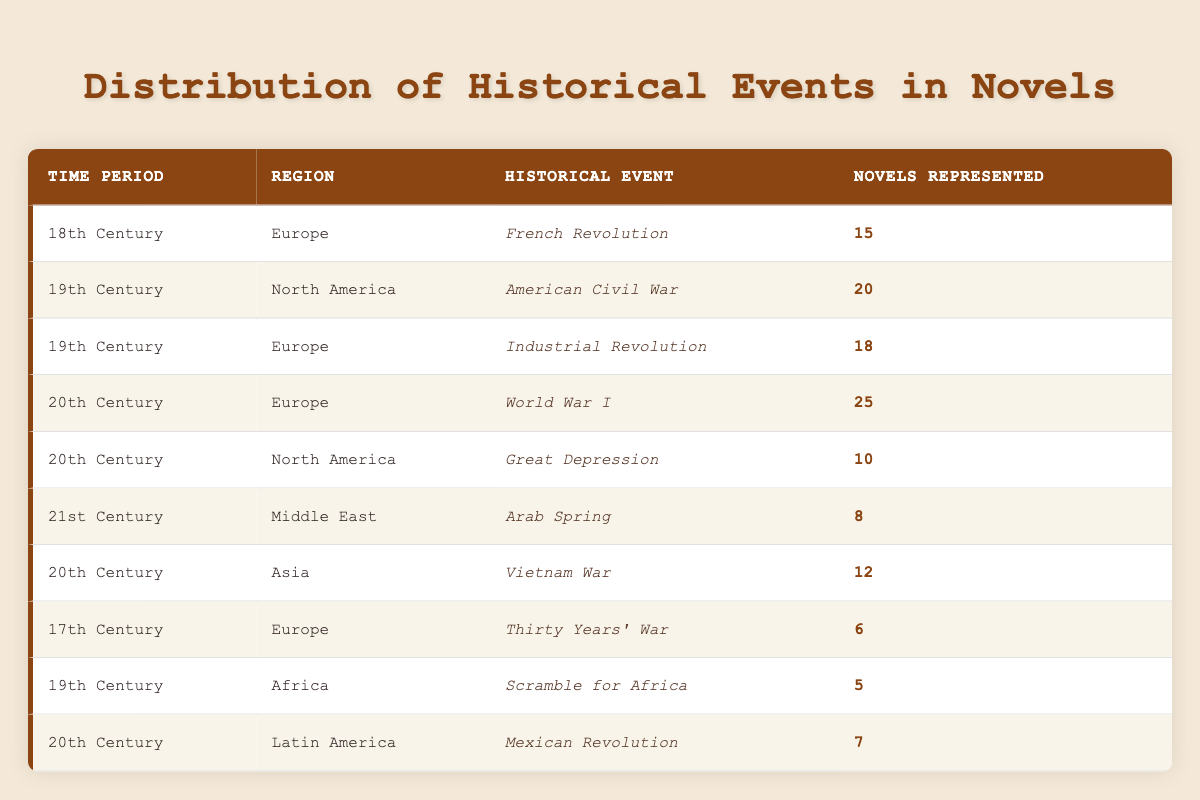What is the historical event represented by the most novels in the table? To find the historical event represented by the most novels, I look for the highest number in the "Novels Represented" column. The event "World War I" with 25 represented novels has the highest count.
Answer: World War I How many novels represent the historical event of the French Revolution? By finding the row corresponding to the "French Revolution," I see that it represents 15 novels.
Answer: 15 What is the total number of novels represented for the 20th century across all regions listed in the table? To find the total for the 20th century, I add the novels from each row associated with the 20th century: 25 (World War I) + 10 (Great Depression) + 12 (Vietnam War) + 7 (Mexican Revolution) = 64.
Answer: 64 Is the Scramble for Africa represented by more novels than the Thirty Years' War? The Scramble for Africa has 5 novels represented, while the Thirty Years' War has 6. Therefore, the Scramble for Africa is represented by fewer novels than the Thirty Years' War.
Answer: No Which time period has the least number of novels represented? I compare the "Novels Represented" for each time period. The 17th Century has 6 represented novels, which is the lowest count among all time periods listed.
Answer: 17th Century What is the difference in the number of novels represented between the American Civil War and the Great Depression? The American Civil War has 20 novels, while the Great Depression has 10. The difference is 20 - 10 = 10.
Answer: 10 Are there any novels that represent a historical event in Africa during the 20th Century? In the table, the only historical event in Africa listed is the Scramble for Africa in the 19th Century, indicating there are no novels from the 20th Century from Africa.
Answer: No What is the average number of novels represented for the 19th Century? For the 19th Century, the novels represented are: 20 (American Civil War) + 18 (Industrial Revolution) + 5 (Scramble for Africa) = 43 total novels. There are 3 events, so the average is 43 / 3 ≈ 14.33.
Answer: 14.33 